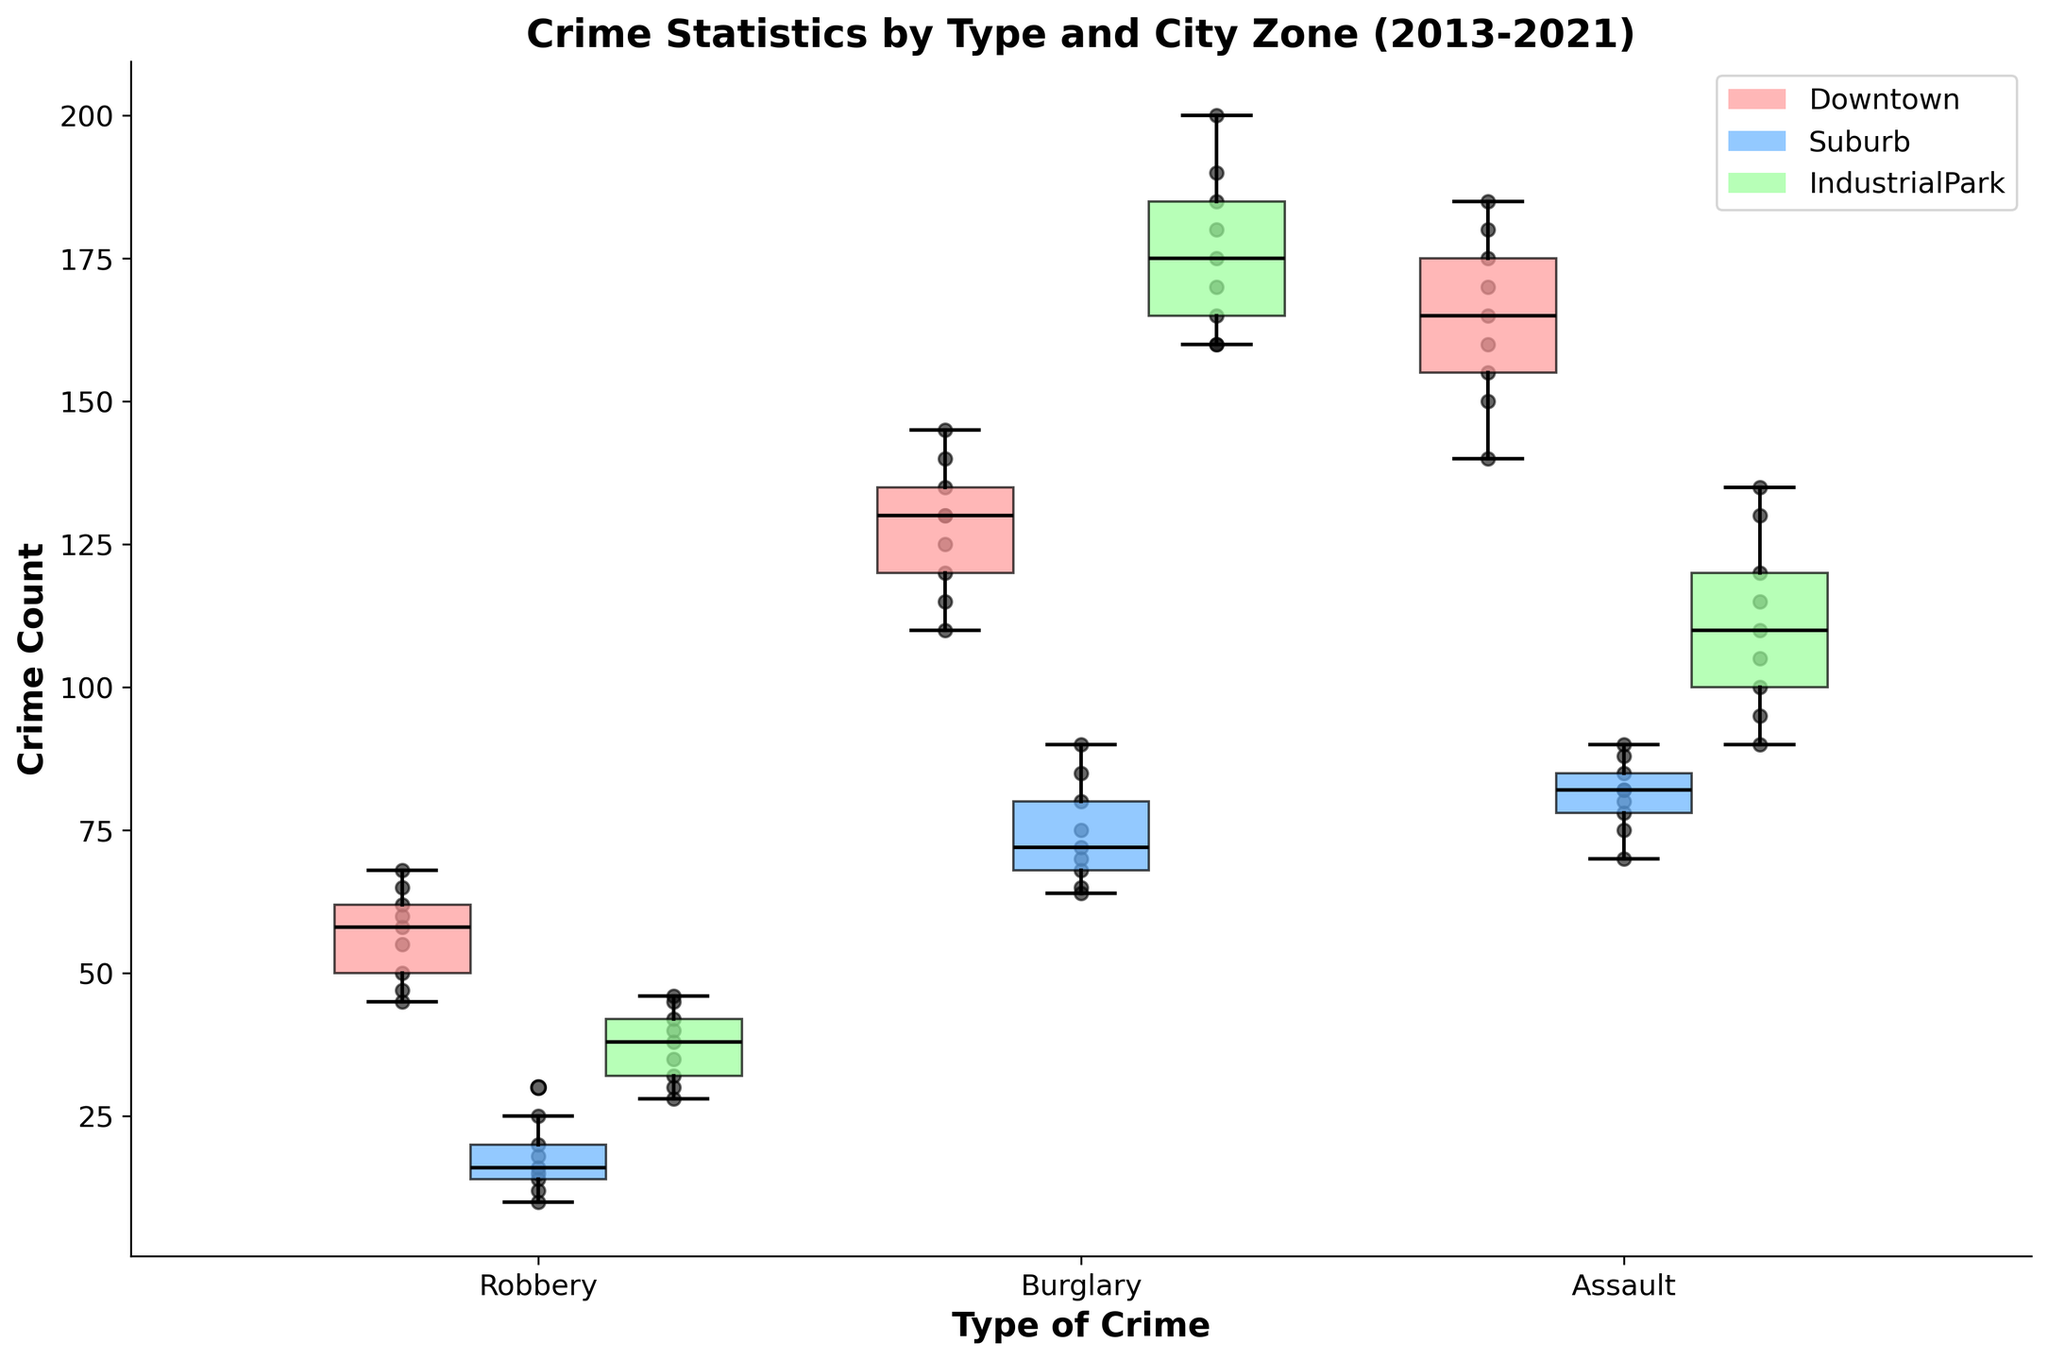What are the types of crime shown in the plot? The title of the plot is "Crime Statistics by Type and City Zone (2013-2021)". The x-axis displays the type of crimes, which are visible as different categories.
Answer: Robbery, Burglary, Assault Which city zone has the highest median crime count for Assault? In the box plot, the median is represented by the black line within each box. Comparing the medians for Assault across all city zones, the box for Downtown has the highest median position.
Answer: Downtown How does the variability in Burglary crime counts compare between Downtown and Industrial Park? Variability in a box plot is shown by the interquartile range (IQR), which is the distance between the first and third quartiles. The boxes for Burglary show that Industrial Park has a larger IQR compared to Downtown, indicating higher variability.
Answer: Industrial Park has higher variability What is the trend in the number of Robberies in the Suburb over time? The scatter points within the plot show individual data points. Observing the scatter points within the Suburb zone, the number of Robberies increases consistently over the years.
Answer: Increasing Which crime type has the lowest median count in the Suburb zone? By examining the median lines within each box for the Suburb zone, it's clear that the box for Robbery has the lowest median line position.
Answer: Robbery Comparing the quartile ranges for Assault, which zone appears to have the least spread in data? The spread in the data is represented by the distance between the bottom and top of the box (the interquartile range). For Assault, the Suburb zone displays the smallest interquartile range, suggesting the least spread.
Answer: Suburb Are there any outliers visible in the Robbery crime counts for Industrial Park? Outliers in box plots are typically shown as individual dots outside the whiskers. For Robbery crime counts in Industrial Park, there are no dots beyond the whiskers, indicating no outliers.
Answer: No How does the median of Burglary crimes in 2021 compare between Downtown and Suburb? To find these medians, look at the positions of the black lines within the respective boxes for Burglary in 2021 for both Downtown and Suburb. The median line for Downtown is higher than that for Suburb.
Answer: Downtown has a higher median in 2021 